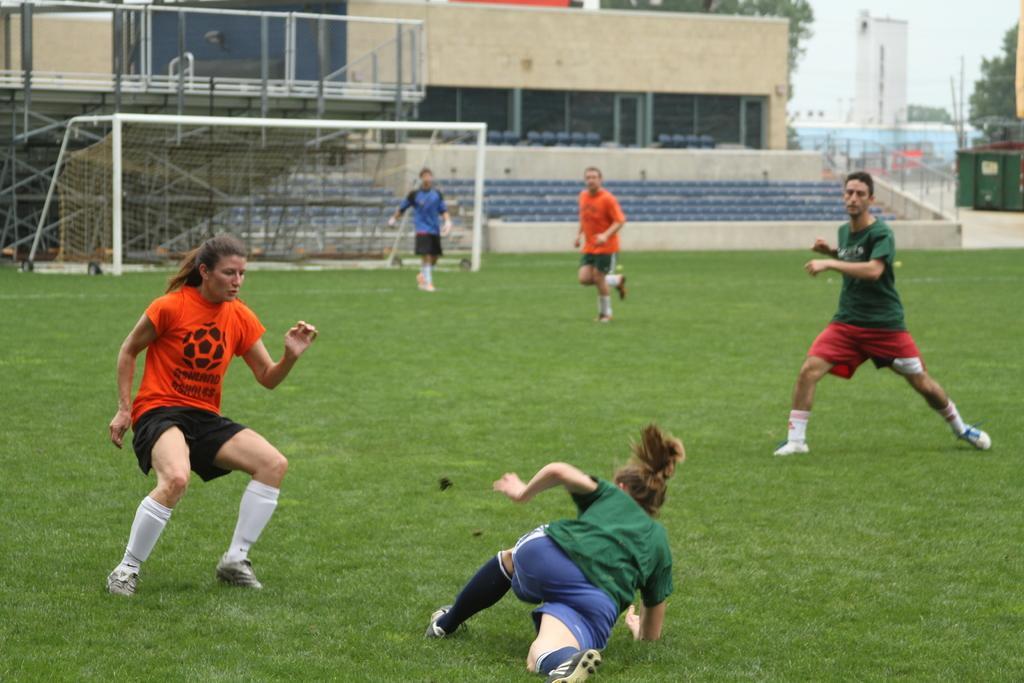How would you summarize this image in a sentence or two? In the image we can see there are people standing on the ground, there is a woman lying down on the ground and the ground is covered with grass. There is a net at the back and there are buildings. Behind there are trees and the image is little blurry at the back. 